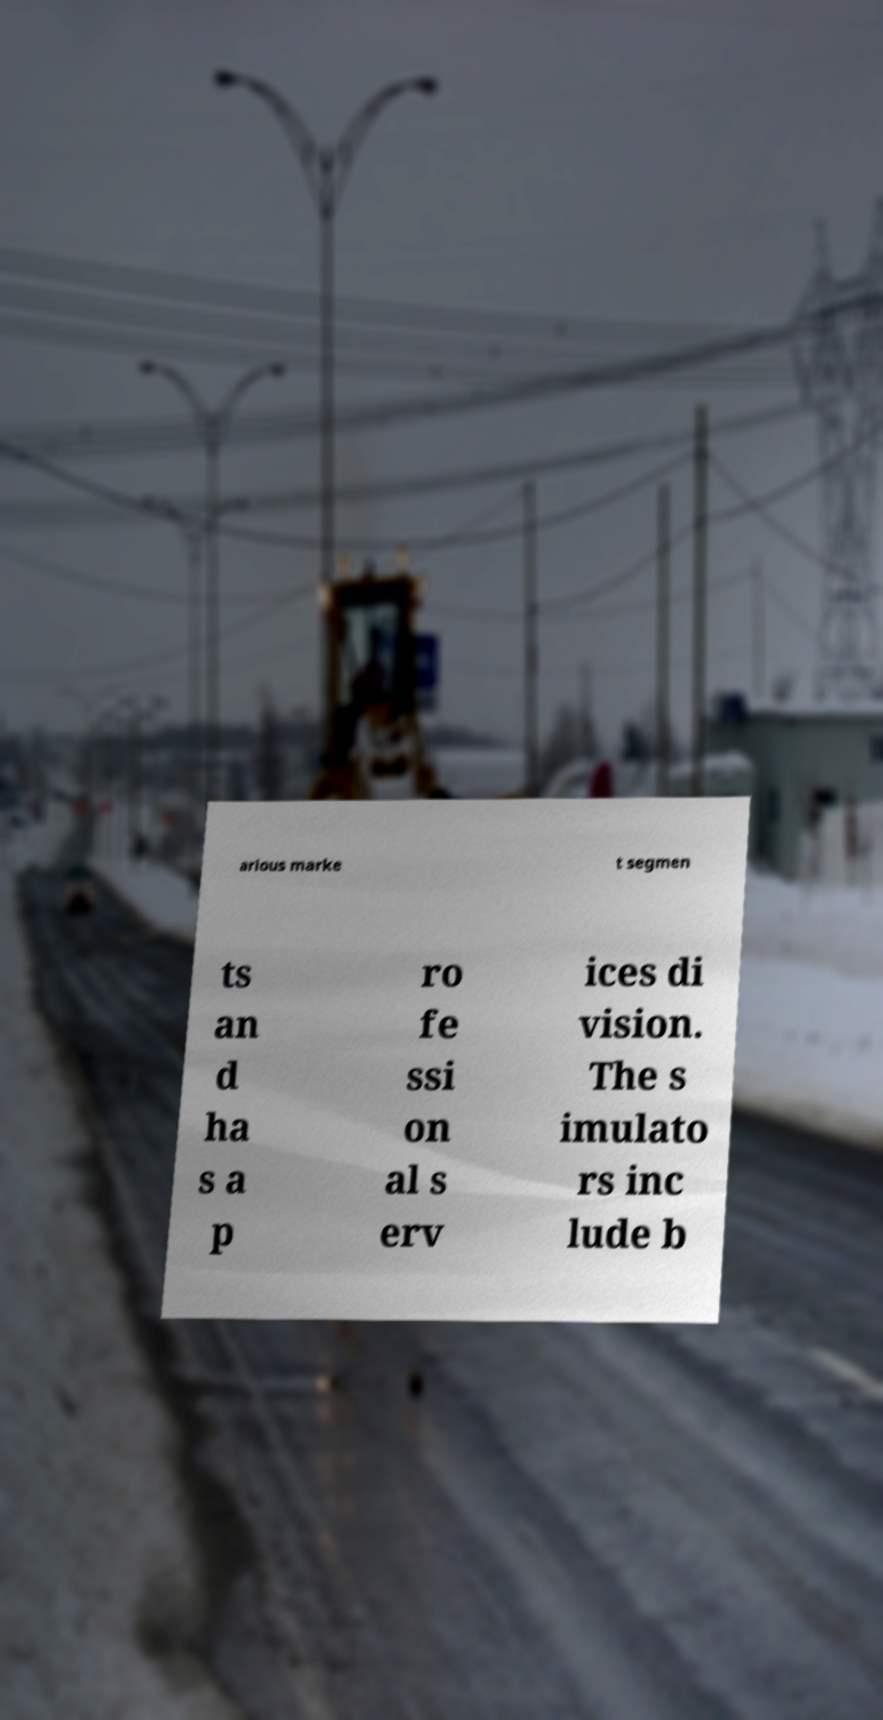I need the written content from this picture converted into text. Can you do that? arious marke t segmen ts an d ha s a p ro fe ssi on al s erv ices di vision. The s imulato rs inc lude b 